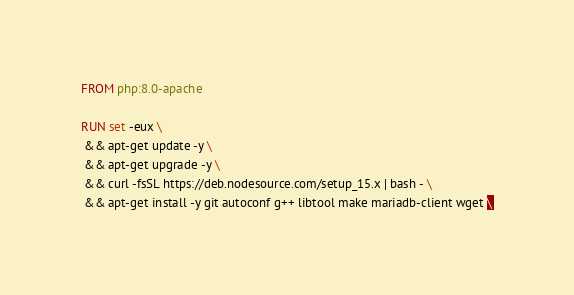Convert code to text. <code><loc_0><loc_0><loc_500><loc_500><_Dockerfile_>FROM php:8.0-apache

RUN set -eux \
 && apt-get update -y \
 && apt-get upgrade -y \
 && curl -fsSL https://deb.nodesource.com/setup_15.x | bash - \
 && apt-get install -y git autoconf g++ libtool make mariadb-client wget \</code> 